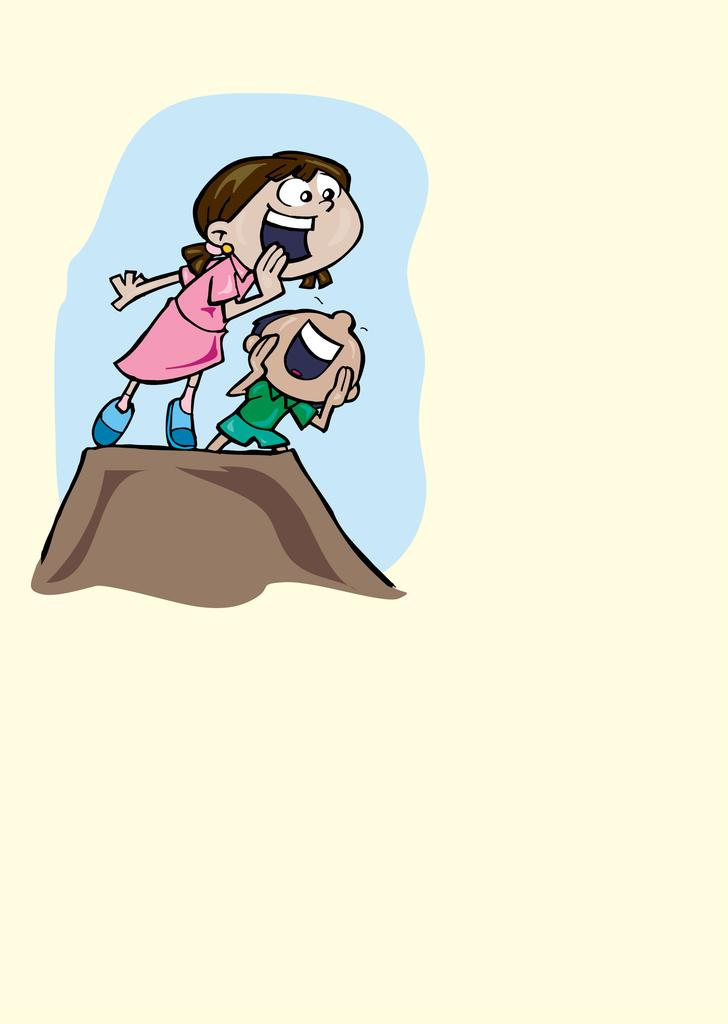What can be seen in the image involving cartoon characters? There is a depiction of two cartoon characters in the image. What colors are the dresses of the cartoon characters? One cartoon character is wearing a green dress, and the other is wearing a pink dress. How many mines are visible in the image? There are no mines present in the image; it features two cartoon characters wearing dresses. What day of the week is depicted in the image? The image does not depict a specific day of the week; it features two cartoon characters wearing dresses. 